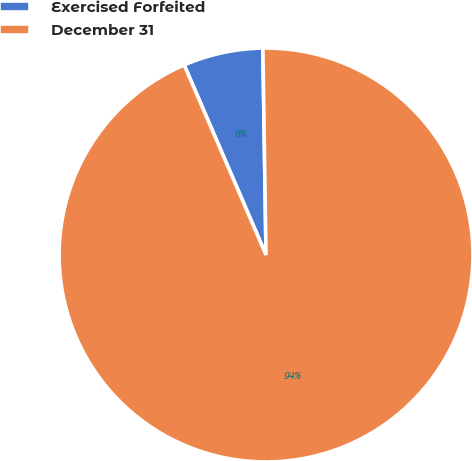<chart> <loc_0><loc_0><loc_500><loc_500><pie_chart><fcel>Exercised Forfeited<fcel>December 31<nl><fcel>6.23%<fcel>93.77%<nl></chart> 